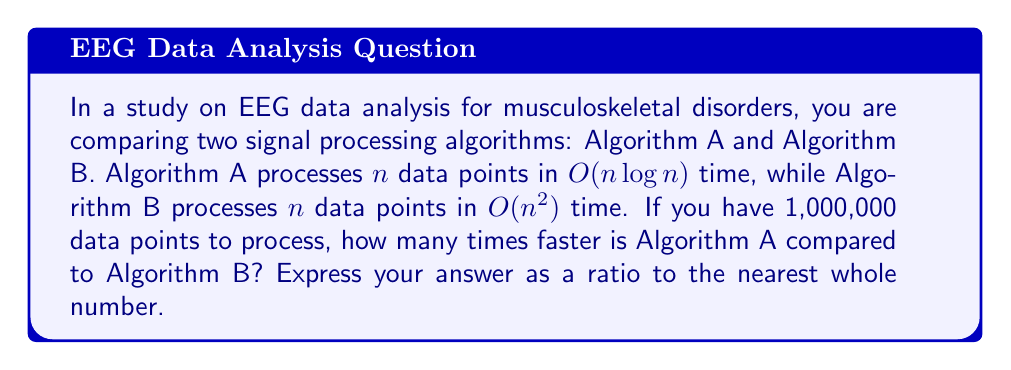Can you answer this question? To solve this problem, we need to compare the time complexities of both algorithms:

1. Algorithm A: $O(n \log n)$
2. Algorithm B: $O(n^2)$

Let's calculate the relative efficiency for $n = 1,000,000$:

1. For Algorithm A:
   $T_A(n) = n \log n = 1,000,000 \times \log(1,000,000)$
   $= 1,000,000 \times 20 = 20,000,000$ (approximately)

2. For Algorithm B:
   $T_B(n) = n^2 = (1,000,000)^2 = 1,000,000,000,000$

To find how many times faster Algorithm A is, we calculate the ratio:

$$\frac{T_B(n)}{T_A(n)} = \frac{1,000,000,000,000}{20,000,000} = 50,000$$

Therefore, Algorithm A is approximately 50,000 times faster than Algorithm B for processing 1,000,000 data points.
Answer: 50,000 